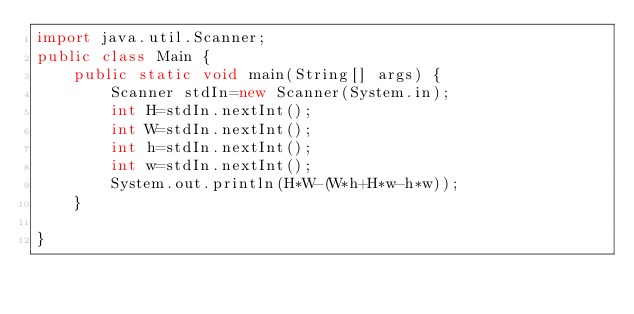Convert code to text. <code><loc_0><loc_0><loc_500><loc_500><_Java_>import java.util.Scanner;
public class Main {
	public static void main(String[] args) {
		Scanner stdIn=new Scanner(System.in);
		int H=stdIn.nextInt();
		int W=stdIn.nextInt();
		int h=stdIn.nextInt();
		int w=stdIn.nextInt();
		System.out.println(H*W-(W*h+H*w-h*w));
	}

}</code> 